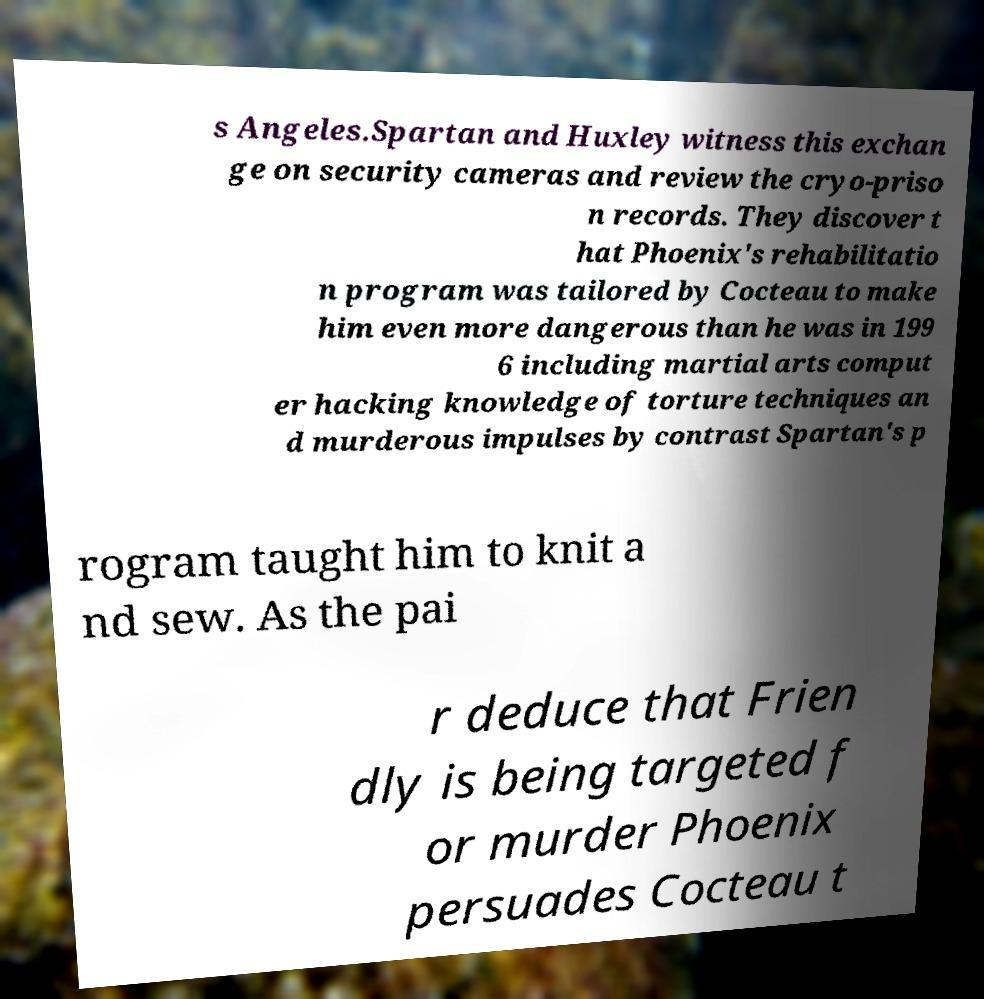Could you extract and type out the text from this image? s Angeles.Spartan and Huxley witness this exchan ge on security cameras and review the cryo-priso n records. They discover t hat Phoenix's rehabilitatio n program was tailored by Cocteau to make him even more dangerous than he was in 199 6 including martial arts comput er hacking knowledge of torture techniques an d murderous impulses by contrast Spartan's p rogram taught him to knit a nd sew. As the pai r deduce that Frien dly is being targeted f or murder Phoenix persuades Cocteau t 